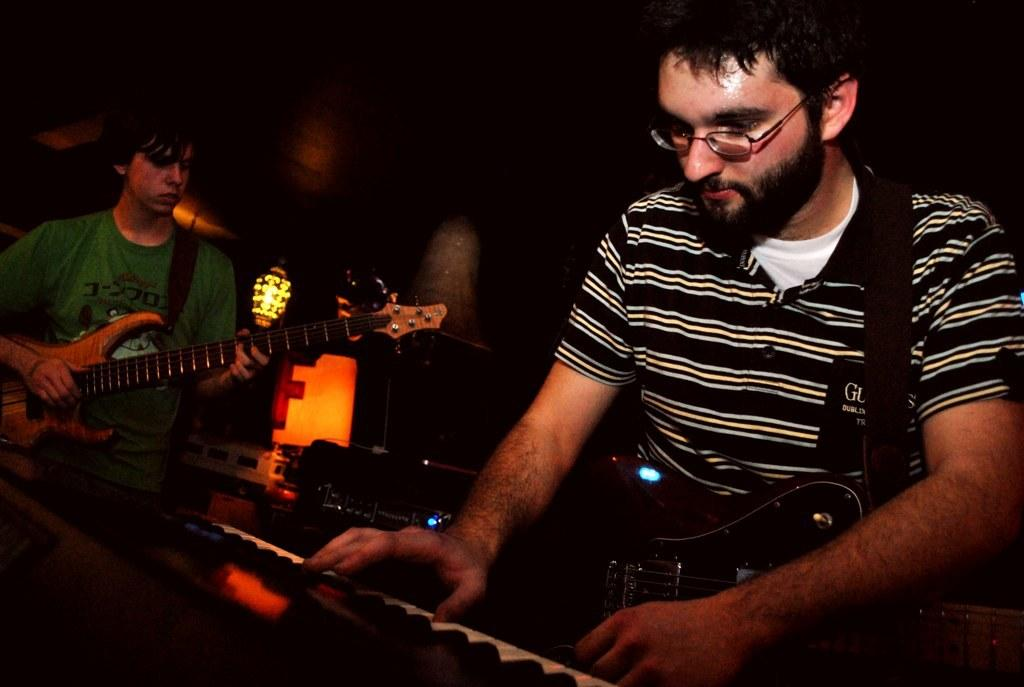What is the person on the right side of the image doing? The person on the right side is holding a guitar and playing a piano. What instrument is the person on the left side of the image playing? The person on the left side is playing a guitar. How many people are present in the image? There are two people in the image. What type of disease can be seen affecting the person on the left side of the image? There is no disease present in the image; both people are playing musical instruments. Can you tell me how many whips are visible in the image? There are no whips present in the image. 